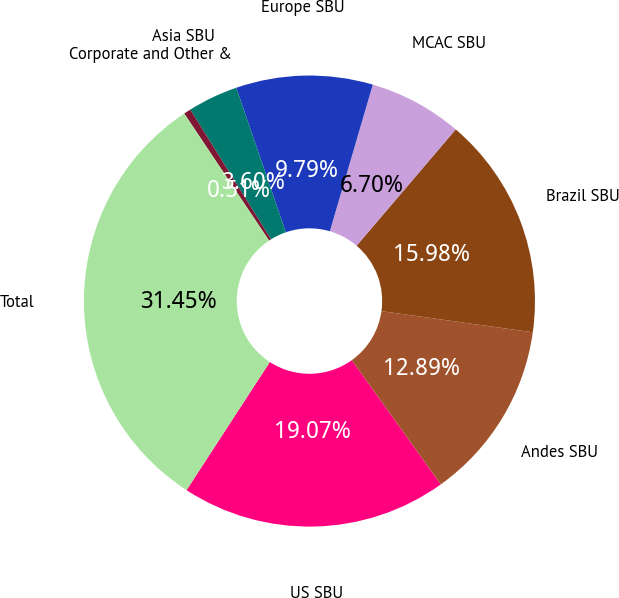<chart> <loc_0><loc_0><loc_500><loc_500><pie_chart><fcel>US SBU<fcel>Andes SBU<fcel>Brazil SBU<fcel>MCAC SBU<fcel>Europe SBU<fcel>Asia SBU<fcel>Corporate and Other &<fcel>Total<nl><fcel>19.07%<fcel>12.89%<fcel>15.98%<fcel>6.7%<fcel>9.79%<fcel>3.6%<fcel>0.51%<fcel>31.45%<nl></chart> 